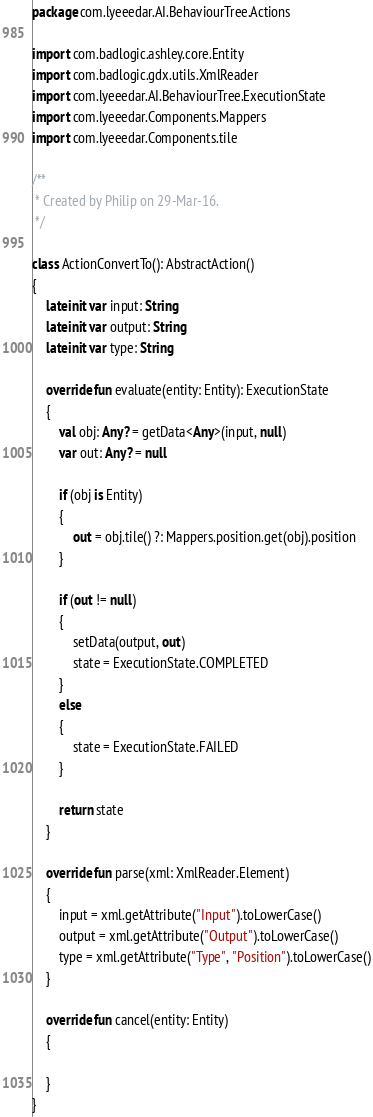Convert code to text. <code><loc_0><loc_0><loc_500><loc_500><_Kotlin_>package com.lyeeedar.AI.BehaviourTree.Actions

import com.badlogic.ashley.core.Entity
import com.badlogic.gdx.utils.XmlReader
import com.lyeeedar.AI.BehaviourTree.ExecutionState
import com.lyeeedar.Components.Mappers
import com.lyeeedar.Components.tile

/**
 * Created by Philip on 29-Mar-16.
 */

class ActionConvertTo(): AbstractAction()
{
	lateinit var input: String
	lateinit var output: String
	lateinit var type: String

	override fun evaluate(entity: Entity): ExecutionState
	{
		val obj: Any? = getData<Any>(input, null)
		var out: Any? = null

		if (obj is Entity)
		{
			out = obj.tile() ?: Mappers.position.get(obj).position
		}

		if (out != null)
		{
			setData(output, out)
			state = ExecutionState.COMPLETED
		}
		else
		{
			state = ExecutionState.FAILED
		}

		return state
	}

	override fun parse(xml: XmlReader.Element)
	{
		input = xml.getAttribute("Input").toLowerCase()
		output = xml.getAttribute("Output").toLowerCase()
		type = xml.getAttribute("Type", "Position").toLowerCase()
	}

	override fun cancel(entity: Entity)
	{

	}
}</code> 